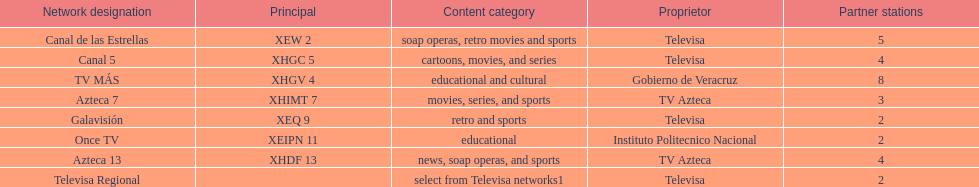Name each of tv azteca's network names. Azteca 7, Azteca 13. 